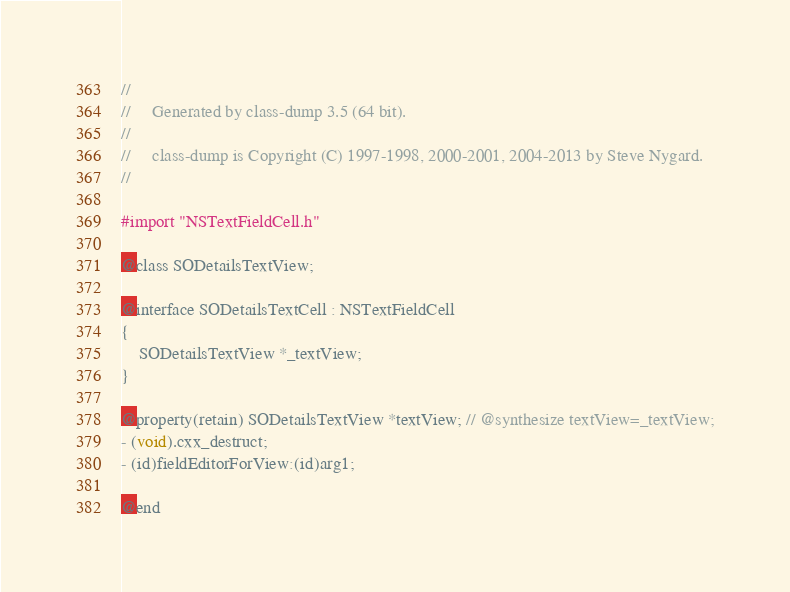Convert code to text. <code><loc_0><loc_0><loc_500><loc_500><_C_>//
//     Generated by class-dump 3.5 (64 bit).
//
//     class-dump is Copyright (C) 1997-1998, 2000-2001, 2004-2013 by Steve Nygard.
//

#import "NSTextFieldCell.h"

@class SODetailsTextView;

@interface SODetailsTextCell : NSTextFieldCell
{
    SODetailsTextView *_textView;
}

@property(retain) SODetailsTextView *textView; // @synthesize textView=_textView;
- (void).cxx_destruct;
- (id)fieldEditorForView:(id)arg1;

@end

</code> 